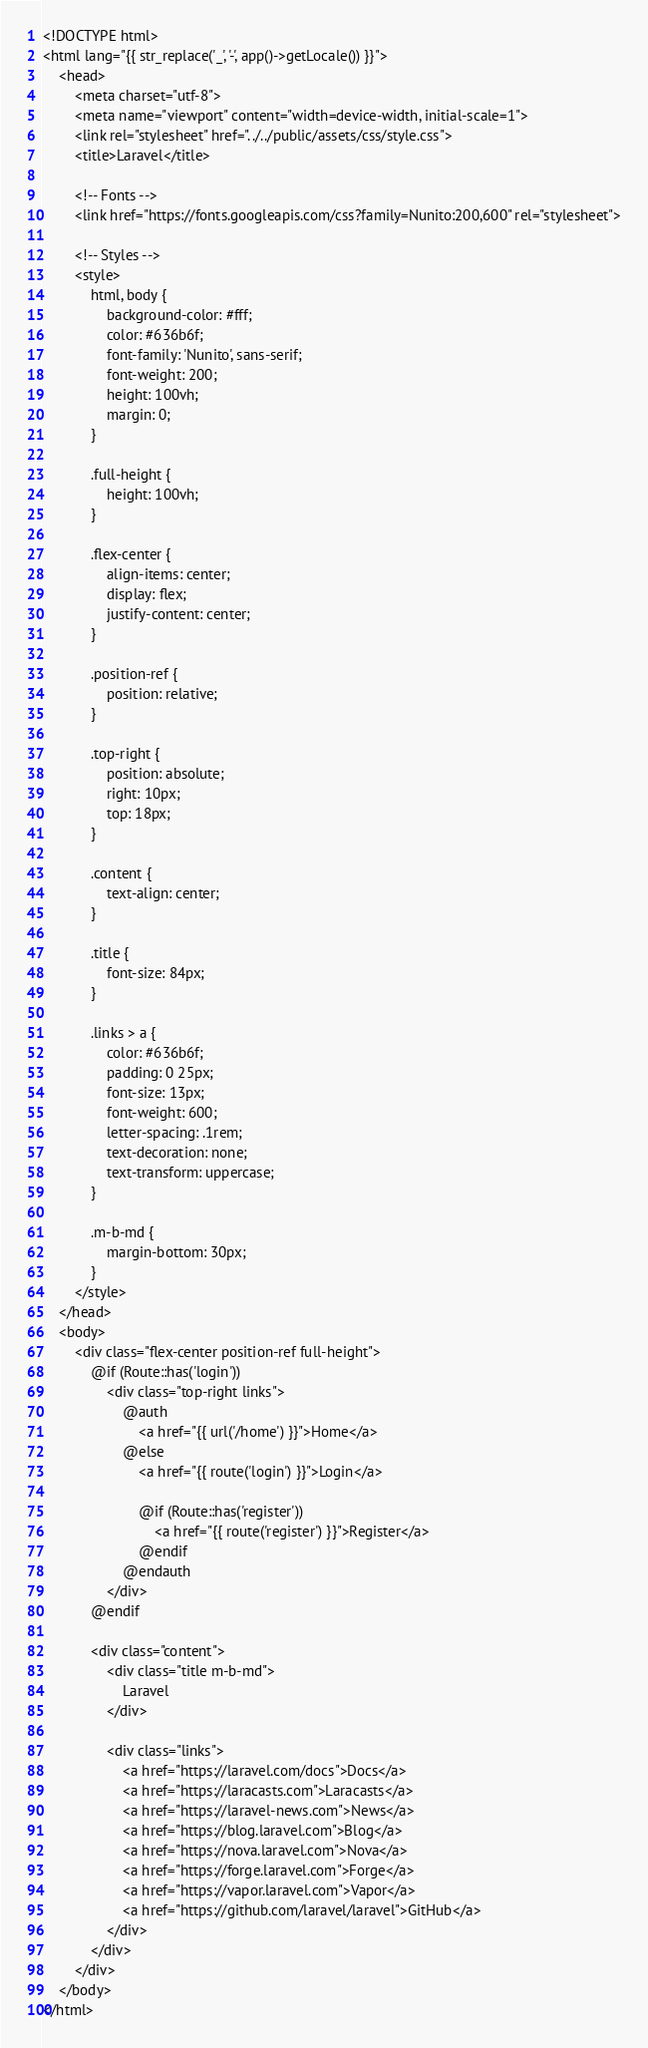<code> <loc_0><loc_0><loc_500><loc_500><_PHP_><!DOCTYPE html>
<html lang="{{ str_replace('_', '-', app()->getLocale()) }}">
    <head>
        <meta charset="utf-8">
        <meta name="viewport" content="width=device-width, initial-scale=1">
        <link rel="stylesheet" href="../../public/assets/css/style.css">
        <title>Laravel</title>

        <!-- Fonts -->
        <link href="https://fonts.googleapis.com/css?family=Nunito:200,600" rel="stylesheet">

        <!-- Styles -->
        <style>
            html, body {
                background-color: #fff;
                color: #636b6f;
                font-family: 'Nunito', sans-serif;
                font-weight: 200;
                height: 100vh;
                margin: 0;
            }

            .full-height {
                height: 100vh;
            }

            .flex-center {
                align-items: center;
                display: flex;
                justify-content: center;
            }

            .position-ref {
                position: relative;
            }

            .top-right {
                position: absolute;
                right: 10px;
                top: 18px;
            }

            .content {
                text-align: center;
            }

            .title {
                font-size: 84px;
            }

            .links > a {
                color: #636b6f;
                padding: 0 25px;
                font-size: 13px;
                font-weight: 600;
                letter-spacing: .1rem;
                text-decoration: none;
                text-transform: uppercase;
            }

            .m-b-md {
                margin-bottom: 30px;
            }
        </style>
    </head>
    <body>
        <div class="flex-center position-ref full-height">
            @if (Route::has('login'))
                <div class="top-right links">
                    @auth
                        <a href="{{ url('/home') }}">Home</a>
                    @else
                        <a href="{{ route('login') }}">Login</a>

                        @if (Route::has('register'))
                            <a href="{{ route('register') }}">Register</a>
                        @endif
                    @endauth
                </div>
            @endif

            <div class="content">
                <div class="title m-b-md">
                    Laravel
                </div>

                <div class="links">
                    <a href="https://laravel.com/docs">Docs</a>
                    <a href="https://laracasts.com">Laracasts</a>
                    <a href="https://laravel-news.com">News</a>
                    <a href="https://blog.laravel.com">Blog</a>
                    <a href="https://nova.laravel.com">Nova</a>
                    <a href="https://forge.laravel.com">Forge</a>
                    <a href="https://vapor.laravel.com">Vapor</a>
                    <a href="https://github.com/laravel/laravel">GitHub</a>
                </div>
            </div>
        </div>
    </body>
</html>
</code> 